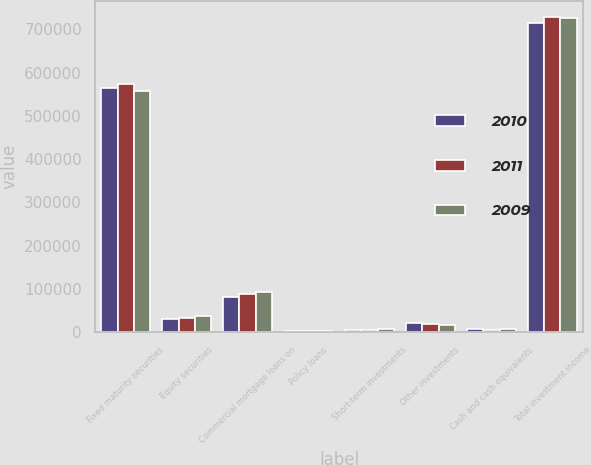<chart> <loc_0><loc_0><loc_500><loc_500><stacked_bar_chart><ecel><fcel>Fixed maturity securities<fcel>Equity securities<fcel>Commercial mortgage loans on<fcel>Policy loans<fcel>Short-term investments<fcel>Other investments<fcel>Cash and cash equivalents<fcel>Total investment income<nl><fcel>2010<fcel>565486<fcel>29645<fcel>80903<fcel>3102<fcel>5351<fcel>21326<fcel>7838<fcel>713651<nl><fcel>2011<fcel>572909<fcel>33864<fcel>88894<fcel>3248<fcel>5259<fcel>19019<fcel>5577<fcel>728770<nl><fcel>2009<fcel>558639<fcel>38189<fcel>92116<fcel>3329<fcel>7933<fcel>17453<fcel>8359<fcel>726018<nl></chart> 